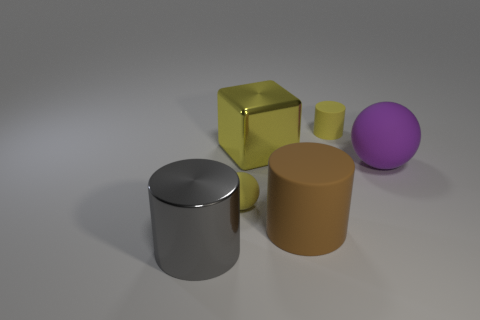What shape is the metallic thing that is the same color as the small cylinder?
Your answer should be compact. Cube. What is the shape of the thing that is on the left side of the yellow metal object and to the right of the gray shiny object?
Your response must be concise. Sphere. There is a large object that is the same material as the large brown cylinder; what shape is it?
Make the answer very short. Sphere. There is a thing to the right of the small yellow matte cylinder; what is it made of?
Your answer should be compact. Rubber. Does the object on the right side of the small cylinder have the same size as the yellow matte object behind the large purple thing?
Keep it short and to the point. No. What is the color of the tiny sphere?
Ensure brevity in your answer.  Yellow. Do the small object that is to the left of the shiny block and the large yellow metallic object have the same shape?
Provide a succinct answer. No. What is the gray thing made of?
Your answer should be very brief. Metal. The purple object that is the same size as the brown rubber thing is what shape?
Make the answer very short. Sphere. Is there another cylinder of the same color as the large shiny cylinder?
Give a very brief answer. No. 